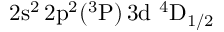<formula> <loc_0><loc_0><loc_500><loc_500>2 s ^ { 2 } \, 2 p ^ { 2 } ( ^ { 3 } P ) \, 3 d ^ { 4 } D _ { 1 / 2 }</formula> 